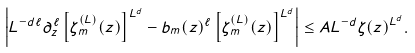Convert formula to latex. <formula><loc_0><loc_0><loc_500><loc_500>\left | L ^ { - d \ell } \partial _ { z } ^ { \ell } \left [ \zeta _ { m } ^ { ( L ) } ( z ) \right ] ^ { L ^ { d } } - b _ { m } ( z ) ^ { \ell } \left [ \zeta _ { m } ^ { ( L ) } ( z ) \right ] ^ { L ^ { d } } \right | \leq A L ^ { - d } \zeta ( z ) ^ { L ^ { d } } .</formula> 